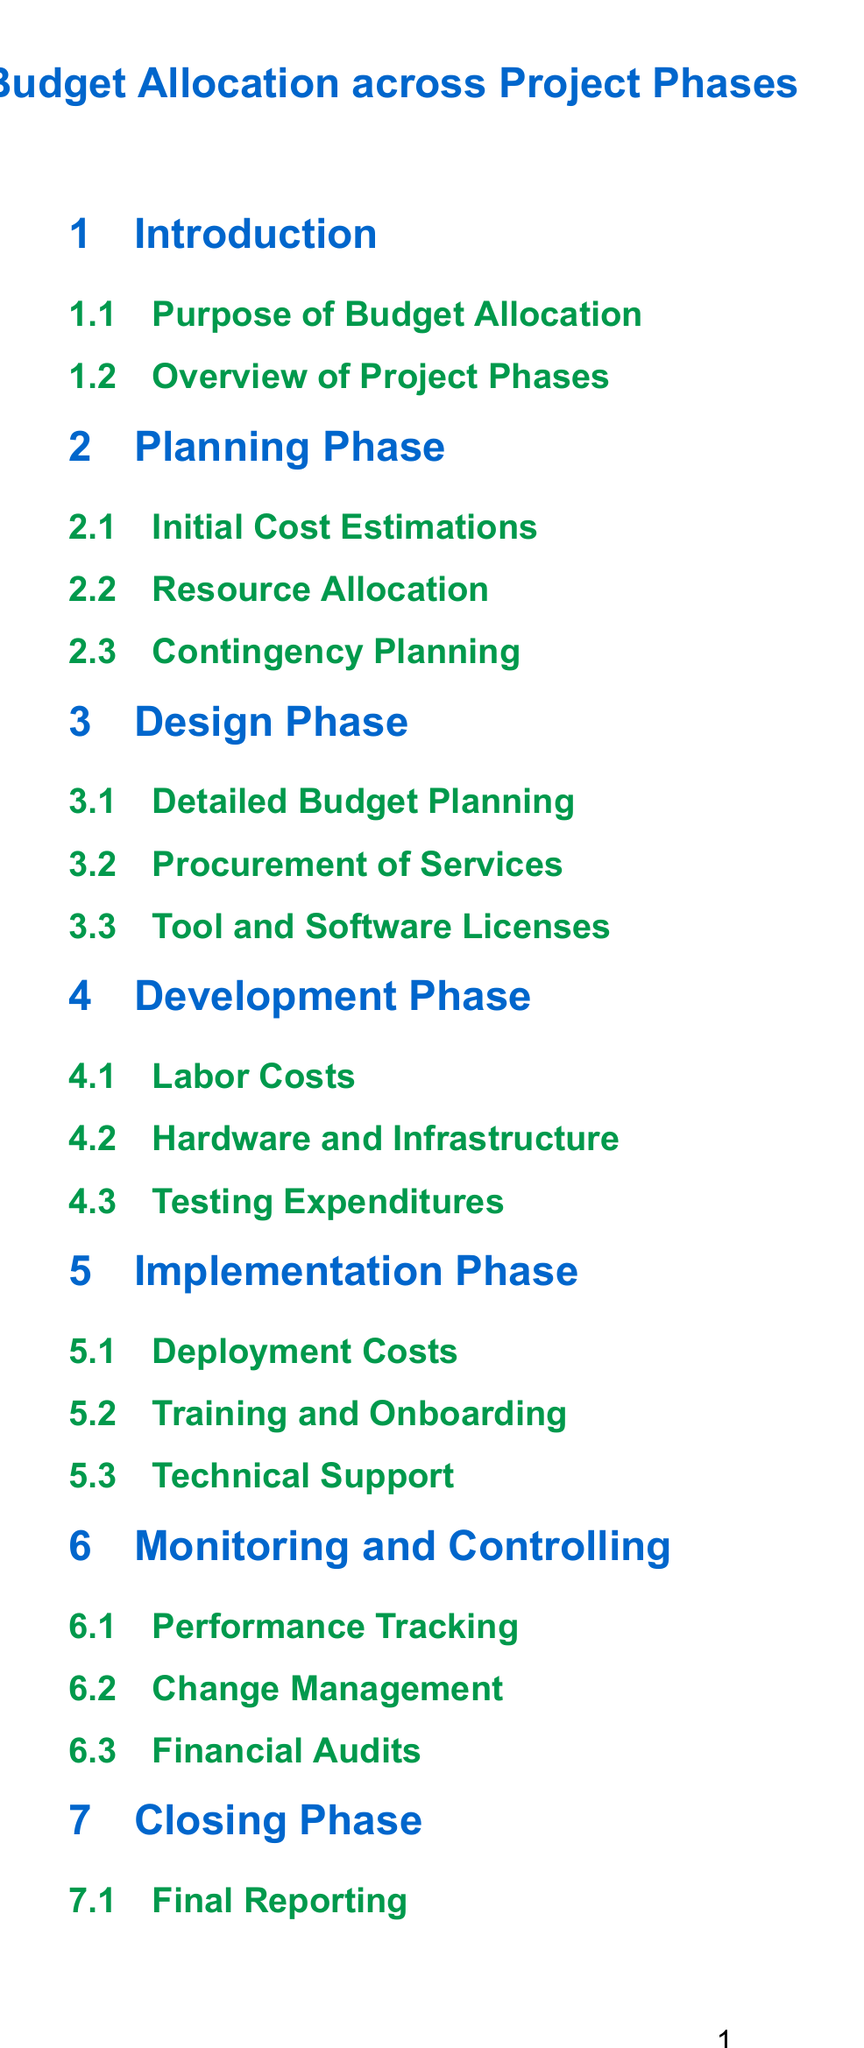What is the title of the document? The title is found at the beginning of the document, representing the overall content.
Answer: Budget Allocation across Project Phases What section follows the "Planning Phase"? This question asks for the next section in the table of contents after "Planning Phase."
Answer: Design Phase How many sub-sections are in the "Development Phase"? The number of sub-sections can be found by counting them under the "Development Phase."
Answer: Three What is the focus of the "Monitoring and Controlling" section? This question pertains to identifying the main topics addressed in the "Monitoring and Controlling" section.
Answer: Performance Tracking Which phase includes "Final Reporting"? This question asks to identify which specific phase includes this activity.
Answer: Closing Phase How many main project phases are listed in the document? Counting the main sections gives the total number of project phases in the document.
Answer: Six What are the last sub-sections in the "Miscellaneous" section? This involves identifying the items listed at the end of a specific section.
Answer: Communication Costs, Legal and Compliance Which section addresses "Technical Support"? This question looks for the section responsible for covering technical assistance.
Answer: Implementation Phase What does the "Cost-benefit Analysis" section summarize? This addresses what the last section in the summary offers insights about.
Answer: Expenditures 